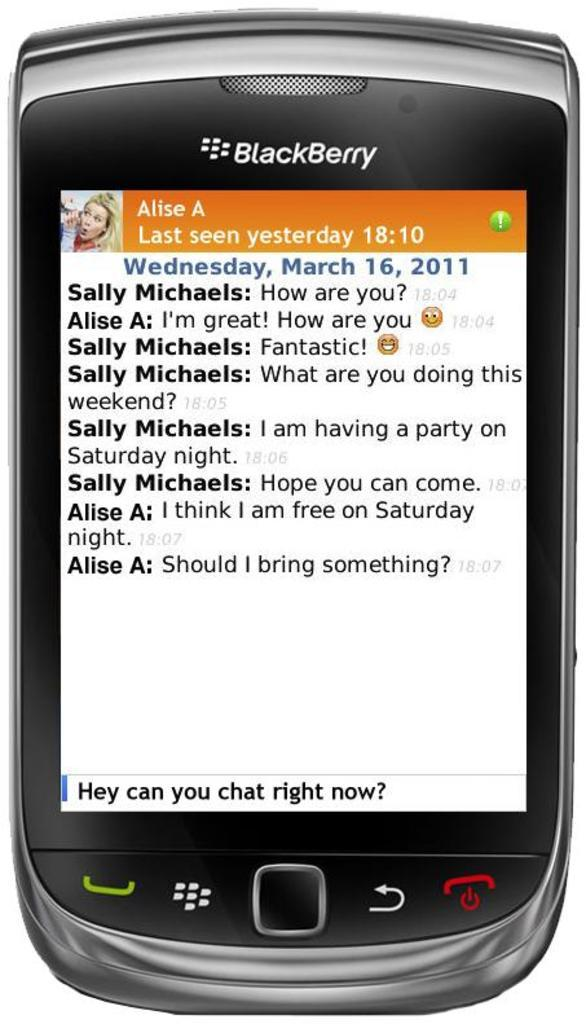<image>
Write a terse but informative summary of the picture. A picture of a BlackBerry conversation with a woman Alise A 